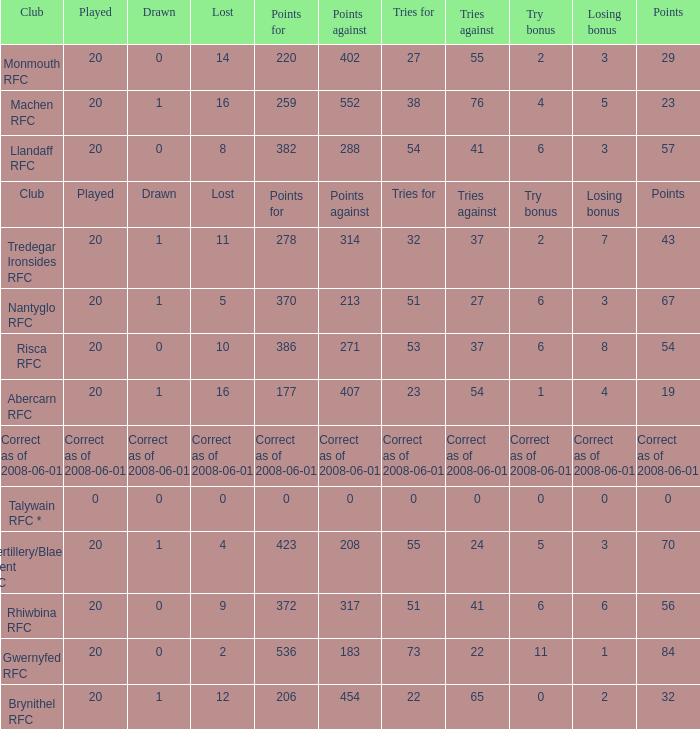If the points were 0, what were the tries for? 0.0. 